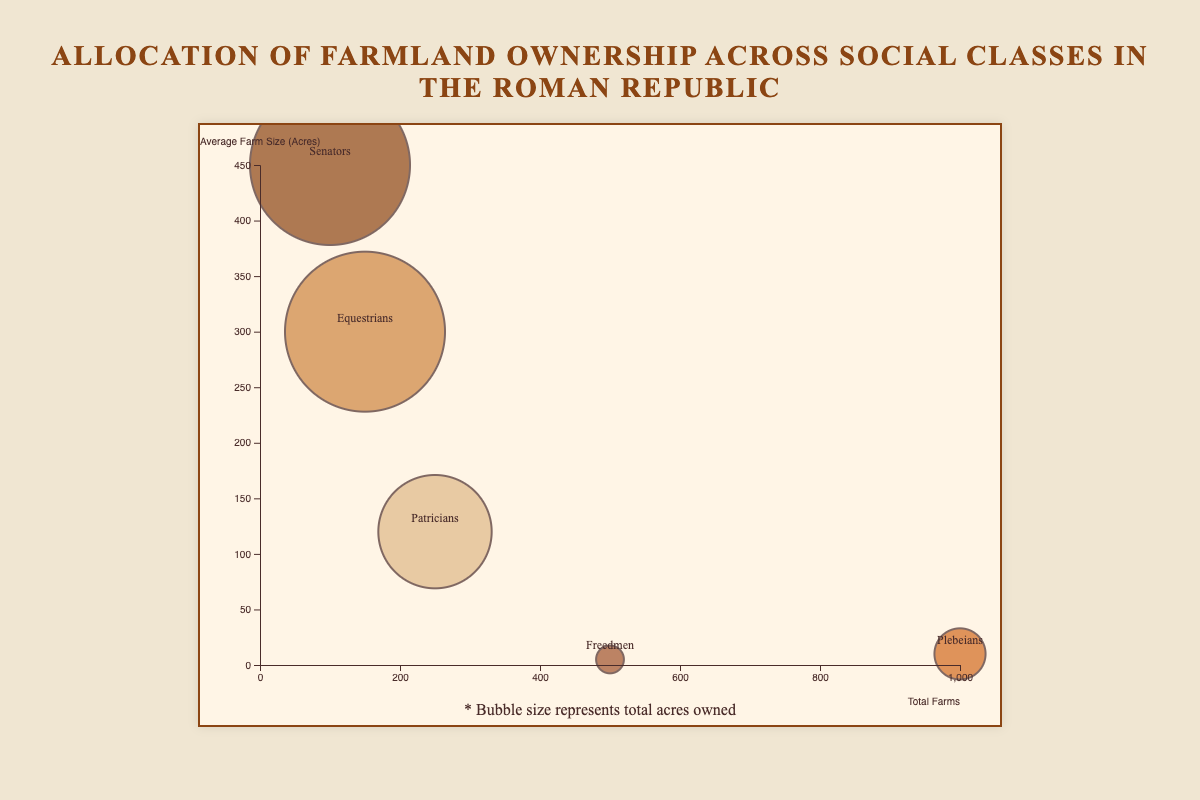What's the social class with the largest bubble size in the chart? The bubble size represents the total acres owned. The "Senators" and "Equestrians" both have bubbles of the same large size since they each own 45,000 acres.
Answer: Senators and Equestrians What is the title of the chart? The title is located at the top of the figure, typically in larger font size. It reads "Allocation of Farmland Ownership Across Social Classes in the Roman Republic."
Answer: Allocation of Farmland Ownership Across Social Classes in the Roman Republic Which social class has the smallest average farm size in acres, and what is the size? By looking at the y-axis, which represents average farm size in acres, the bubble with the lowest position represents "Freedmen" with an average farm size of 5 acres.
Answer: Freedmen, 5 acres Which social class has the highest number of total farms? The x-axis represents the total number of farms. The bubble farthest to the right represents the "Plebeians" with 1,000 total farms.
Answer: Plebeians How does the total acres owned by Patricians compare to Plebeians? The total acres owned is represented by the bubble size. The Patricians' bubble is larger than the Plebeians' bubble, indicating that Patricians own more acres.
Answer: Patricians own more What is the relationship between total farms and average farm size for Equestrians? The "Equestrians" bubble is located to the right of the center on the x-axis and slightly above the center on the y-axis, indicating they have 150 farms and an average farm size of 300 acres.
Answer: 150 farms, 300 acres average Comparing Plebeians and Freedmen, which class has a greater total acres owned? The bubble size represents total acres owned. The "Plebeians" have a larger bubble than the "Freedmen," indicating they own more total acres.
Answer: Plebeians Which social class has a similar total acres owned but different average farm sizes? The two bubbles of similar size but at different y-axis positions represent "Senators" and "Equestrians"; both own 45,000 acres but have average farm sizes of 450 acres and 300 acres, respectively.
Answer: Senators and Equestrians What does the text below the chart indicate? The text below the chart typically provides supplementary information about how to interpret it. It reads, "* Bubble size represents total acres owned."
Answer: Bubble size represents total acres owned If the total acres owned by Patricians were doubled, which social class would have a similar total acres owned? Doubling the total acres owned by Patricians from 30,000 to 60,000 acres would make them exceed the Senators' and Equestrians' 45,000 acres. This adjustment would place them in a new dominant position.
Answer: None, they would own the most 